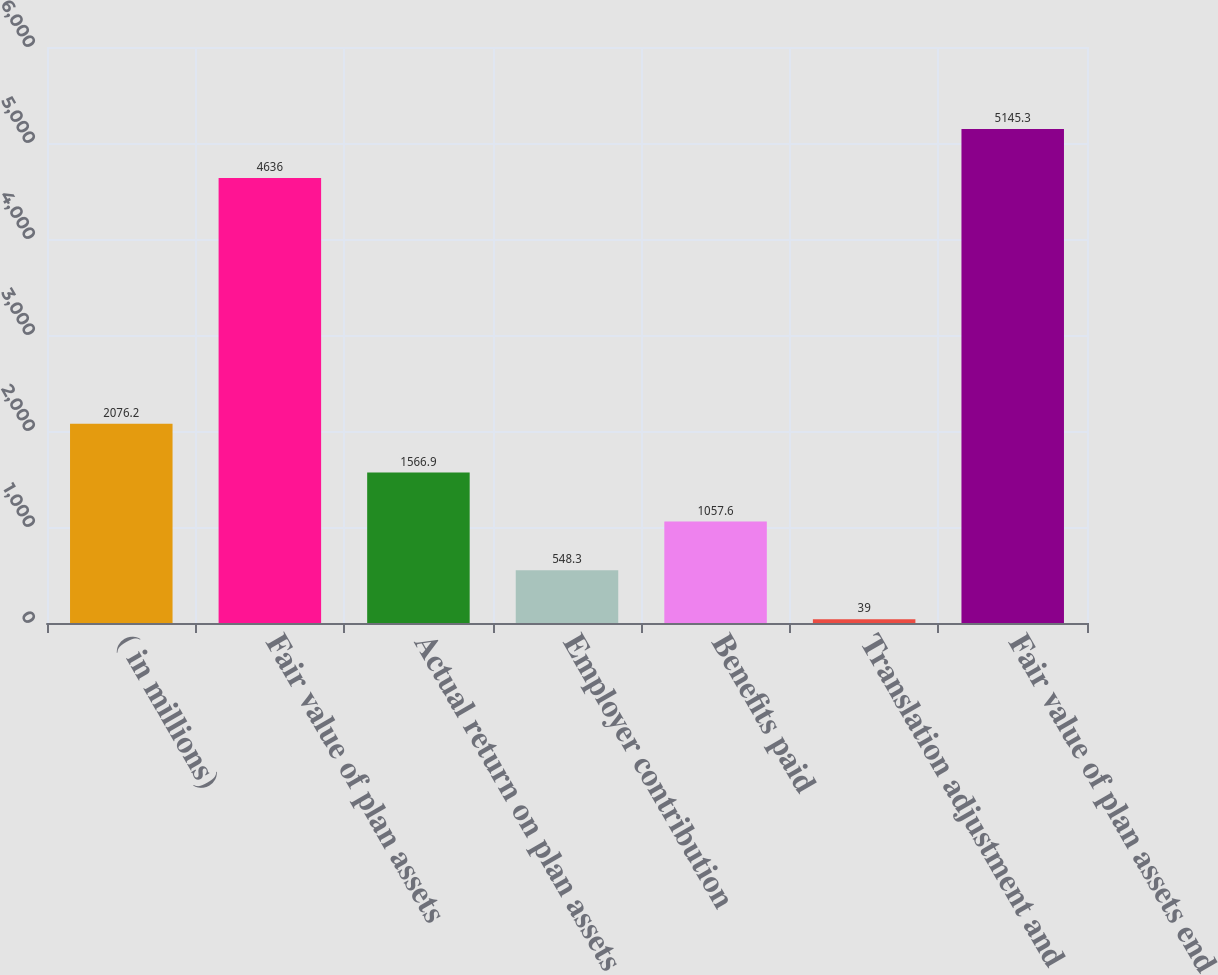Convert chart to OTSL. <chart><loc_0><loc_0><loc_500><loc_500><bar_chart><fcel>( in millions)<fcel>Fair value of plan assets<fcel>Actual return on plan assets<fcel>Employer contribution<fcel>Benefits paid<fcel>Translation adjustment and<fcel>Fair value of plan assets end<nl><fcel>2076.2<fcel>4636<fcel>1566.9<fcel>548.3<fcel>1057.6<fcel>39<fcel>5145.3<nl></chart> 